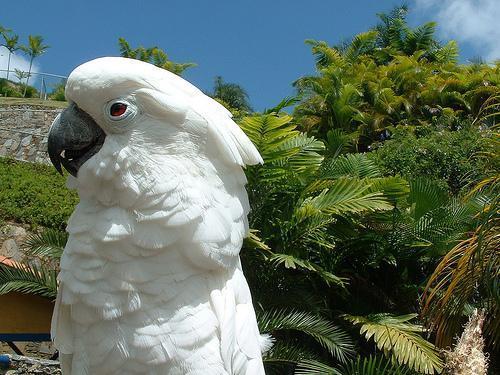How many animals are in this picture?
Give a very brief answer. 1. 